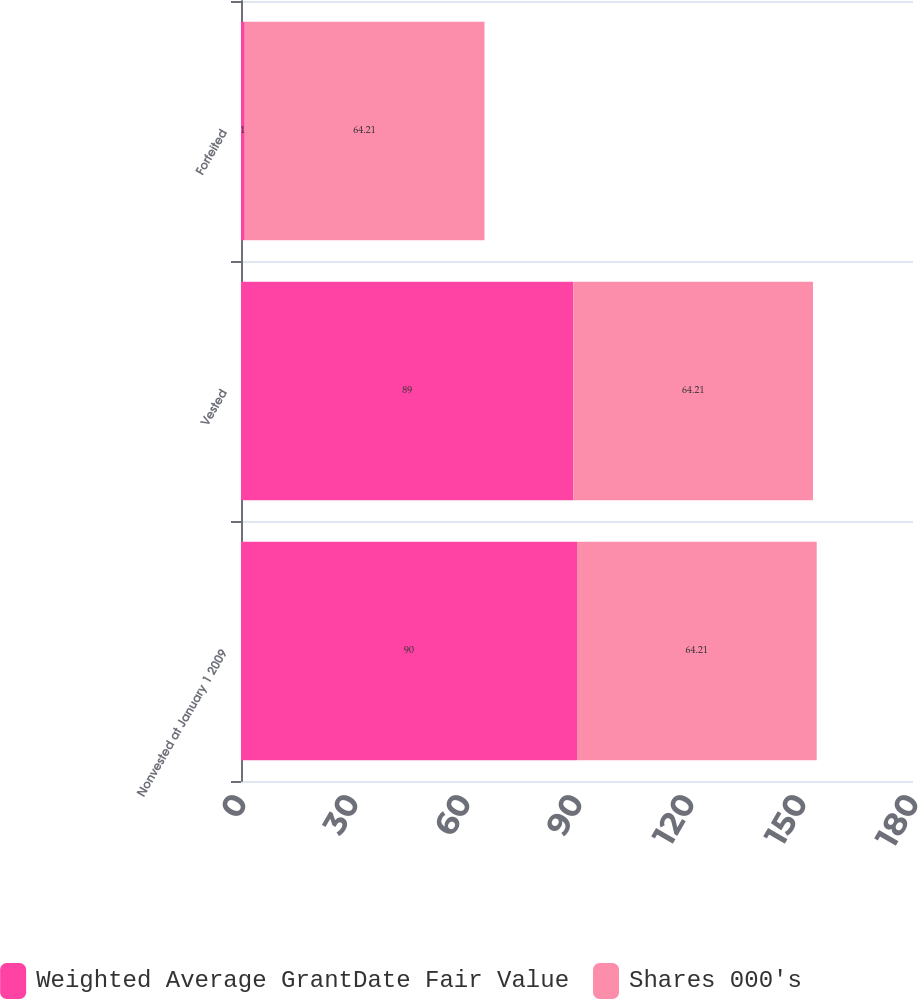<chart> <loc_0><loc_0><loc_500><loc_500><stacked_bar_chart><ecel><fcel>Nonvested at January 1 2009<fcel>Vested<fcel>Forfeited<nl><fcel>Weighted Average GrantDate Fair Value<fcel>90<fcel>89<fcel>1<nl><fcel>Shares 000's<fcel>64.21<fcel>64.21<fcel>64.21<nl></chart> 